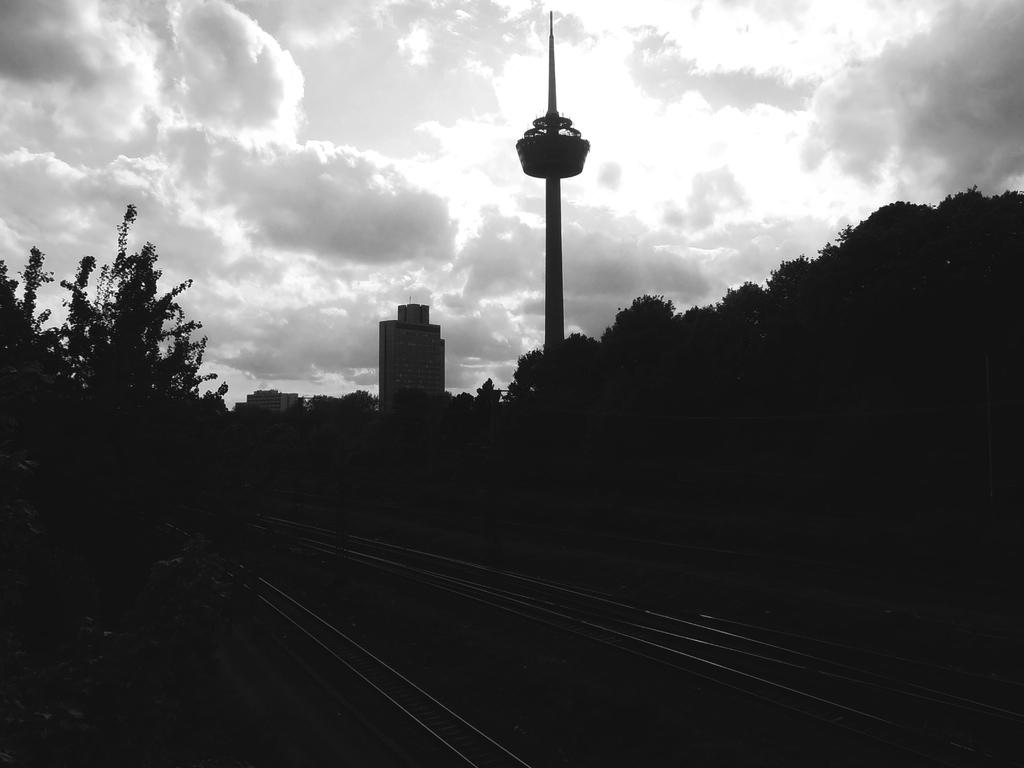What type of transportation infrastructure is present in the image? There are railway tracks in the image. What natural elements can be seen in the image? There are trees visible in the image. What type of structures are in the background of the image? There are buildings in the background of the image. What is visible in the sky in the image? The sky is visible in the background of the image. What tall structure is present in the image? There is a tower in the image. What caption is written on the tower in the image? There is no caption visible on the tower in the image. What type of weather event is occurring in the image? There is no indication of any weather event, such as thunder, in the image. 